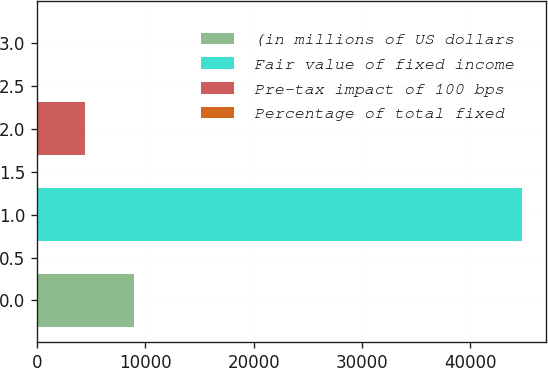<chart> <loc_0><loc_0><loc_500><loc_500><bar_chart><fcel>(in millions of US dollars<fcel>Fair value of fixed income<fcel>Pre-tax impact of 100 bps<fcel>Percentage of total fixed<nl><fcel>8953.48<fcel>44753<fcel>4478.54<fcel>3.6<nl></chart> 